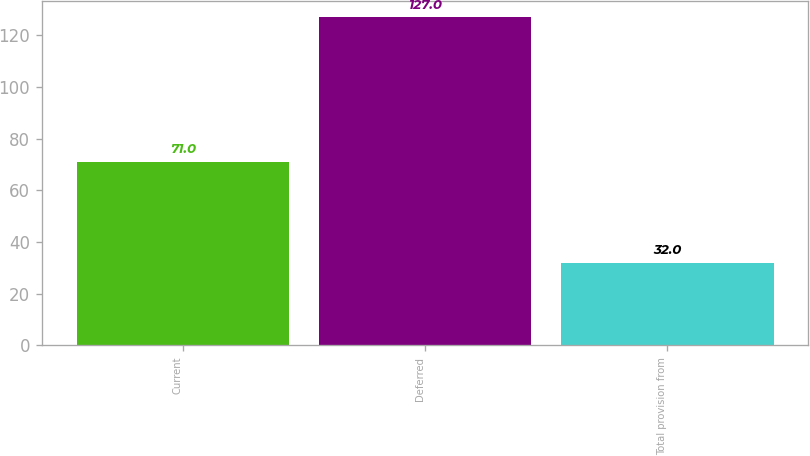Convert chart to OTSL. <chart><loc_0><loc_0><loc_500><loc_500><bar_chart><fcel>Current<fcel>Deferred<fcel>Total provision from<nl><fcel>71<fcel>127<fcel>32<nl></chart> 